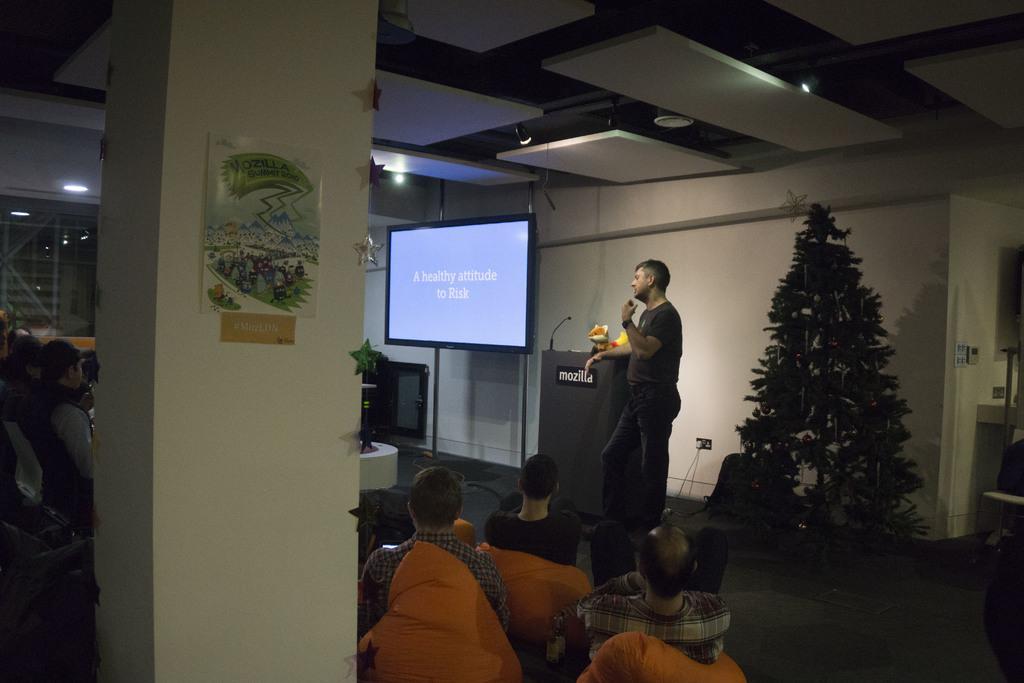In one or two sentences, can you explain what this image depicts? This image is taken indoors. On the left side of the image a few people are sitting on the chairs and there is a pillar with a poster on it. In the background there is a wall with a window. At the top of the image there is a ceiling with a few lights. On the right side of the image there is a Christmas tree on the floor. In the middle of the image there is a television and there is a podium with a few things on it. A man is standing on the floor and a few are sitting on the chairs. 